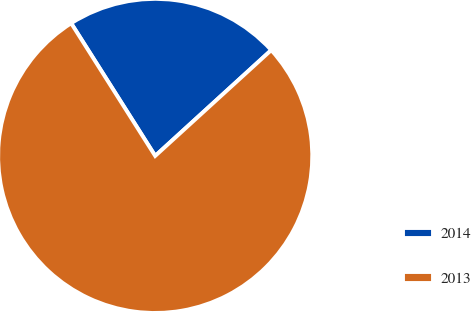Convert chart. <chart><loc_0><loc_0><loc_500><loc_500><pie_chart><fcel>2014<fcel>2013<nl><fcel>22.22%<fcel>77.78%<nl></chart> 